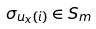Convert formula to latex. <formula><loc_0><loc_0><loc_500><loc_500>\sigma _ { u _ { x } ( i ) } \in S _ { m }</formula> 